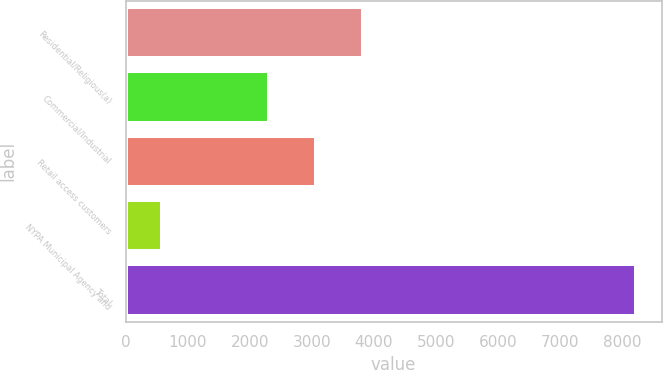<chart> <loc_0><loc_0><loc_500><loc_500><bar_chart><fcel>Residential/Religious(a)<fcel>Commercial/Industrial<fcel>Retail access customers<fcel>NYPA Municipal Agency and<fcel>Total<nl><fcel>3831.2<fcel>2304<fcel>3067.6<fcel>592<fcel>8228<nl></chart> 